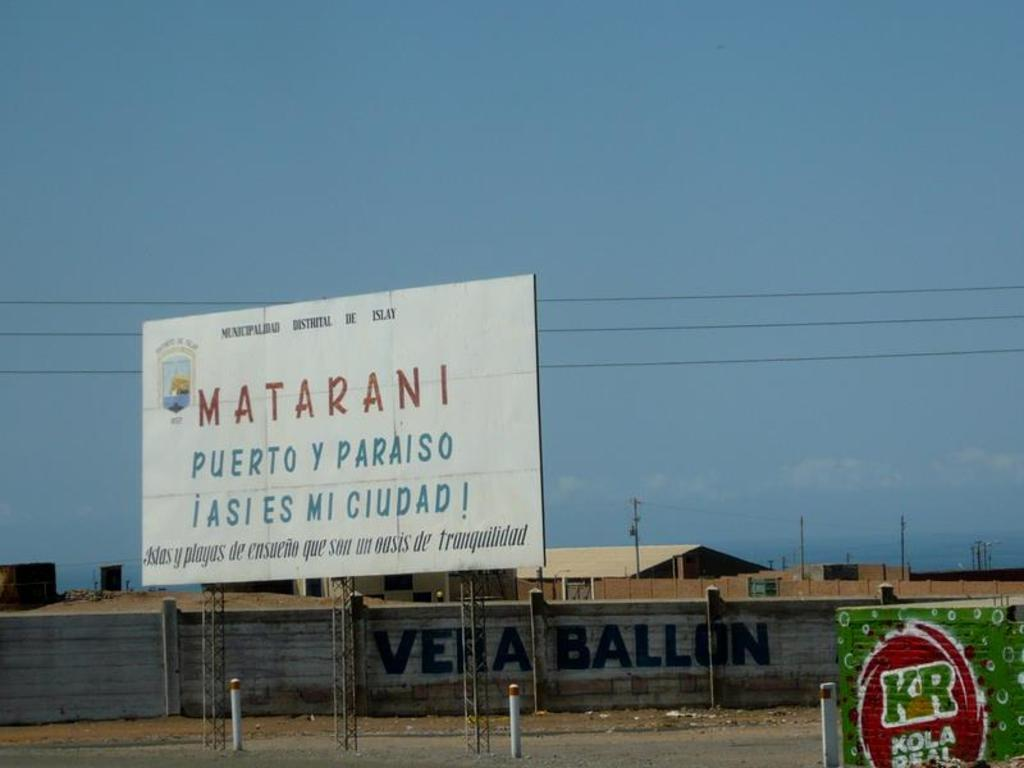<image>
Give a short and clear explanation of the subsequent image. a fence outside with a white Matarani sign above it 